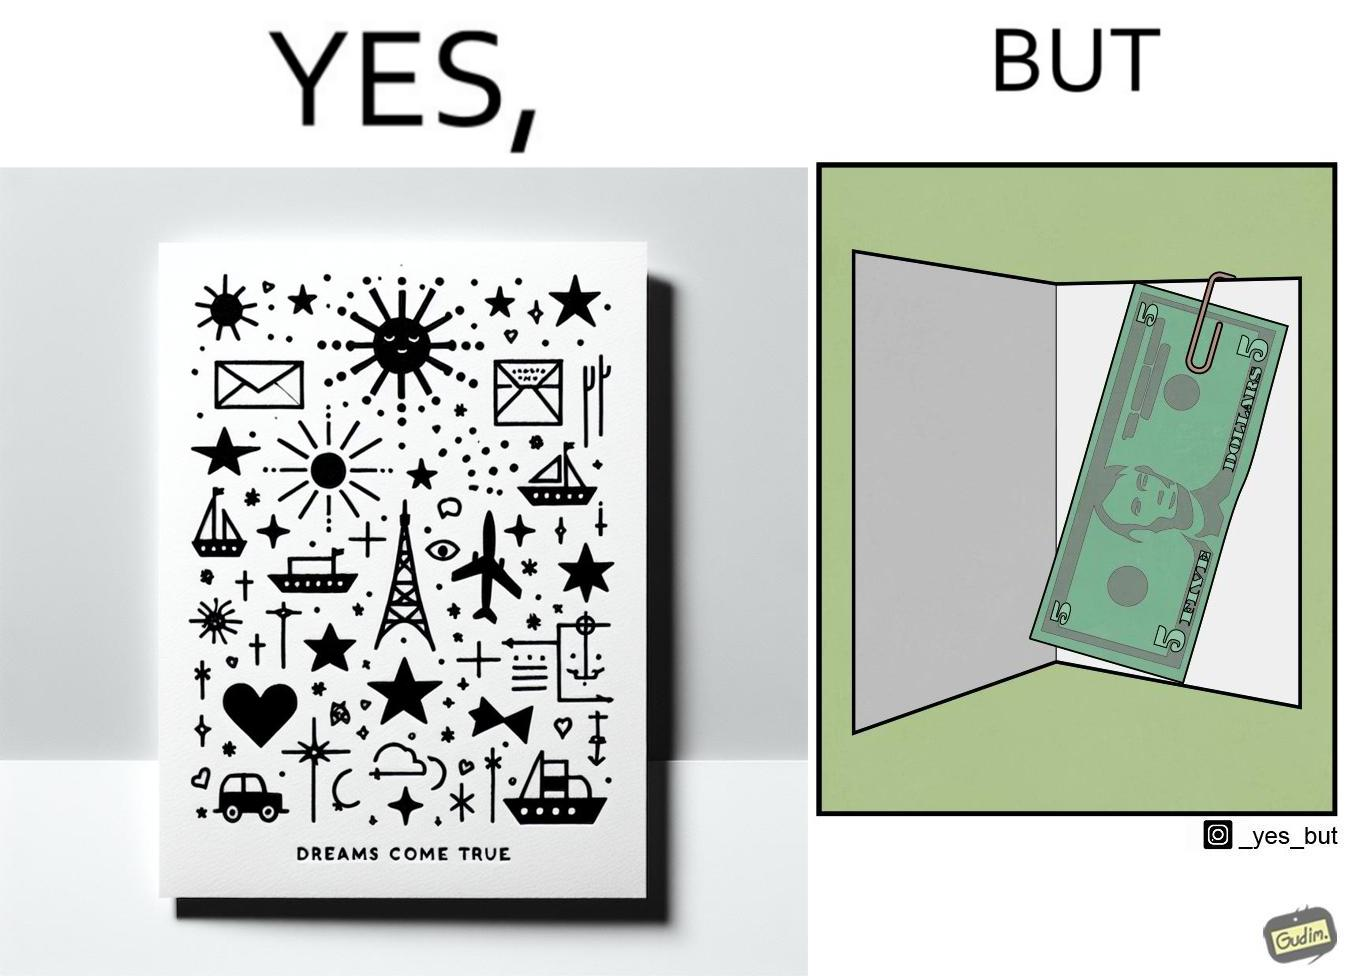What do you see in each half of this image? In the left part of the image: The image shows the front side of a card with the text saying "dreams come true". There are also various drawings of sun, starts, hearts, ships, cars and eiffel tower on the card. In the right part of the image: The image shows a 5 US dollar bill clipped to a card. 